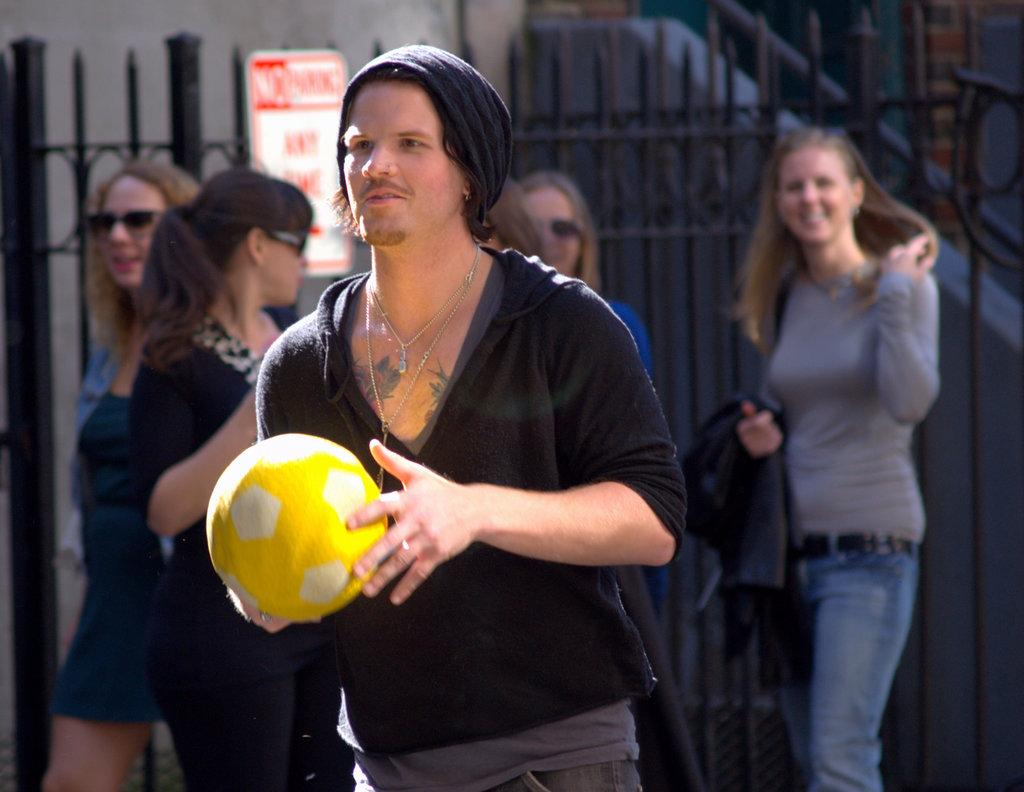What are the people in the image doing? The people in the image are standing on the ground. What is the man holding in his hands? The man is holding a ball in his hands. What can be seen in the background of the image? There is a metal fence and a board with some text in the background of the image. What type of jar is being used to stamp the text on the board in the image? There is no jar or stamping activity present in the image. 